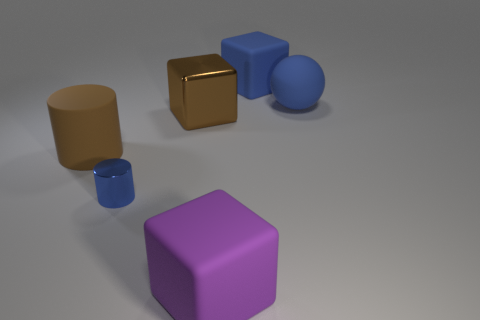Could you tell me what colors the objects are in this image? Certainly! In the image, there is a range of colored objects including a golden cube, a blue sphere, a brown cylinder, a tiny blue cylinder, and a large purple cube. 